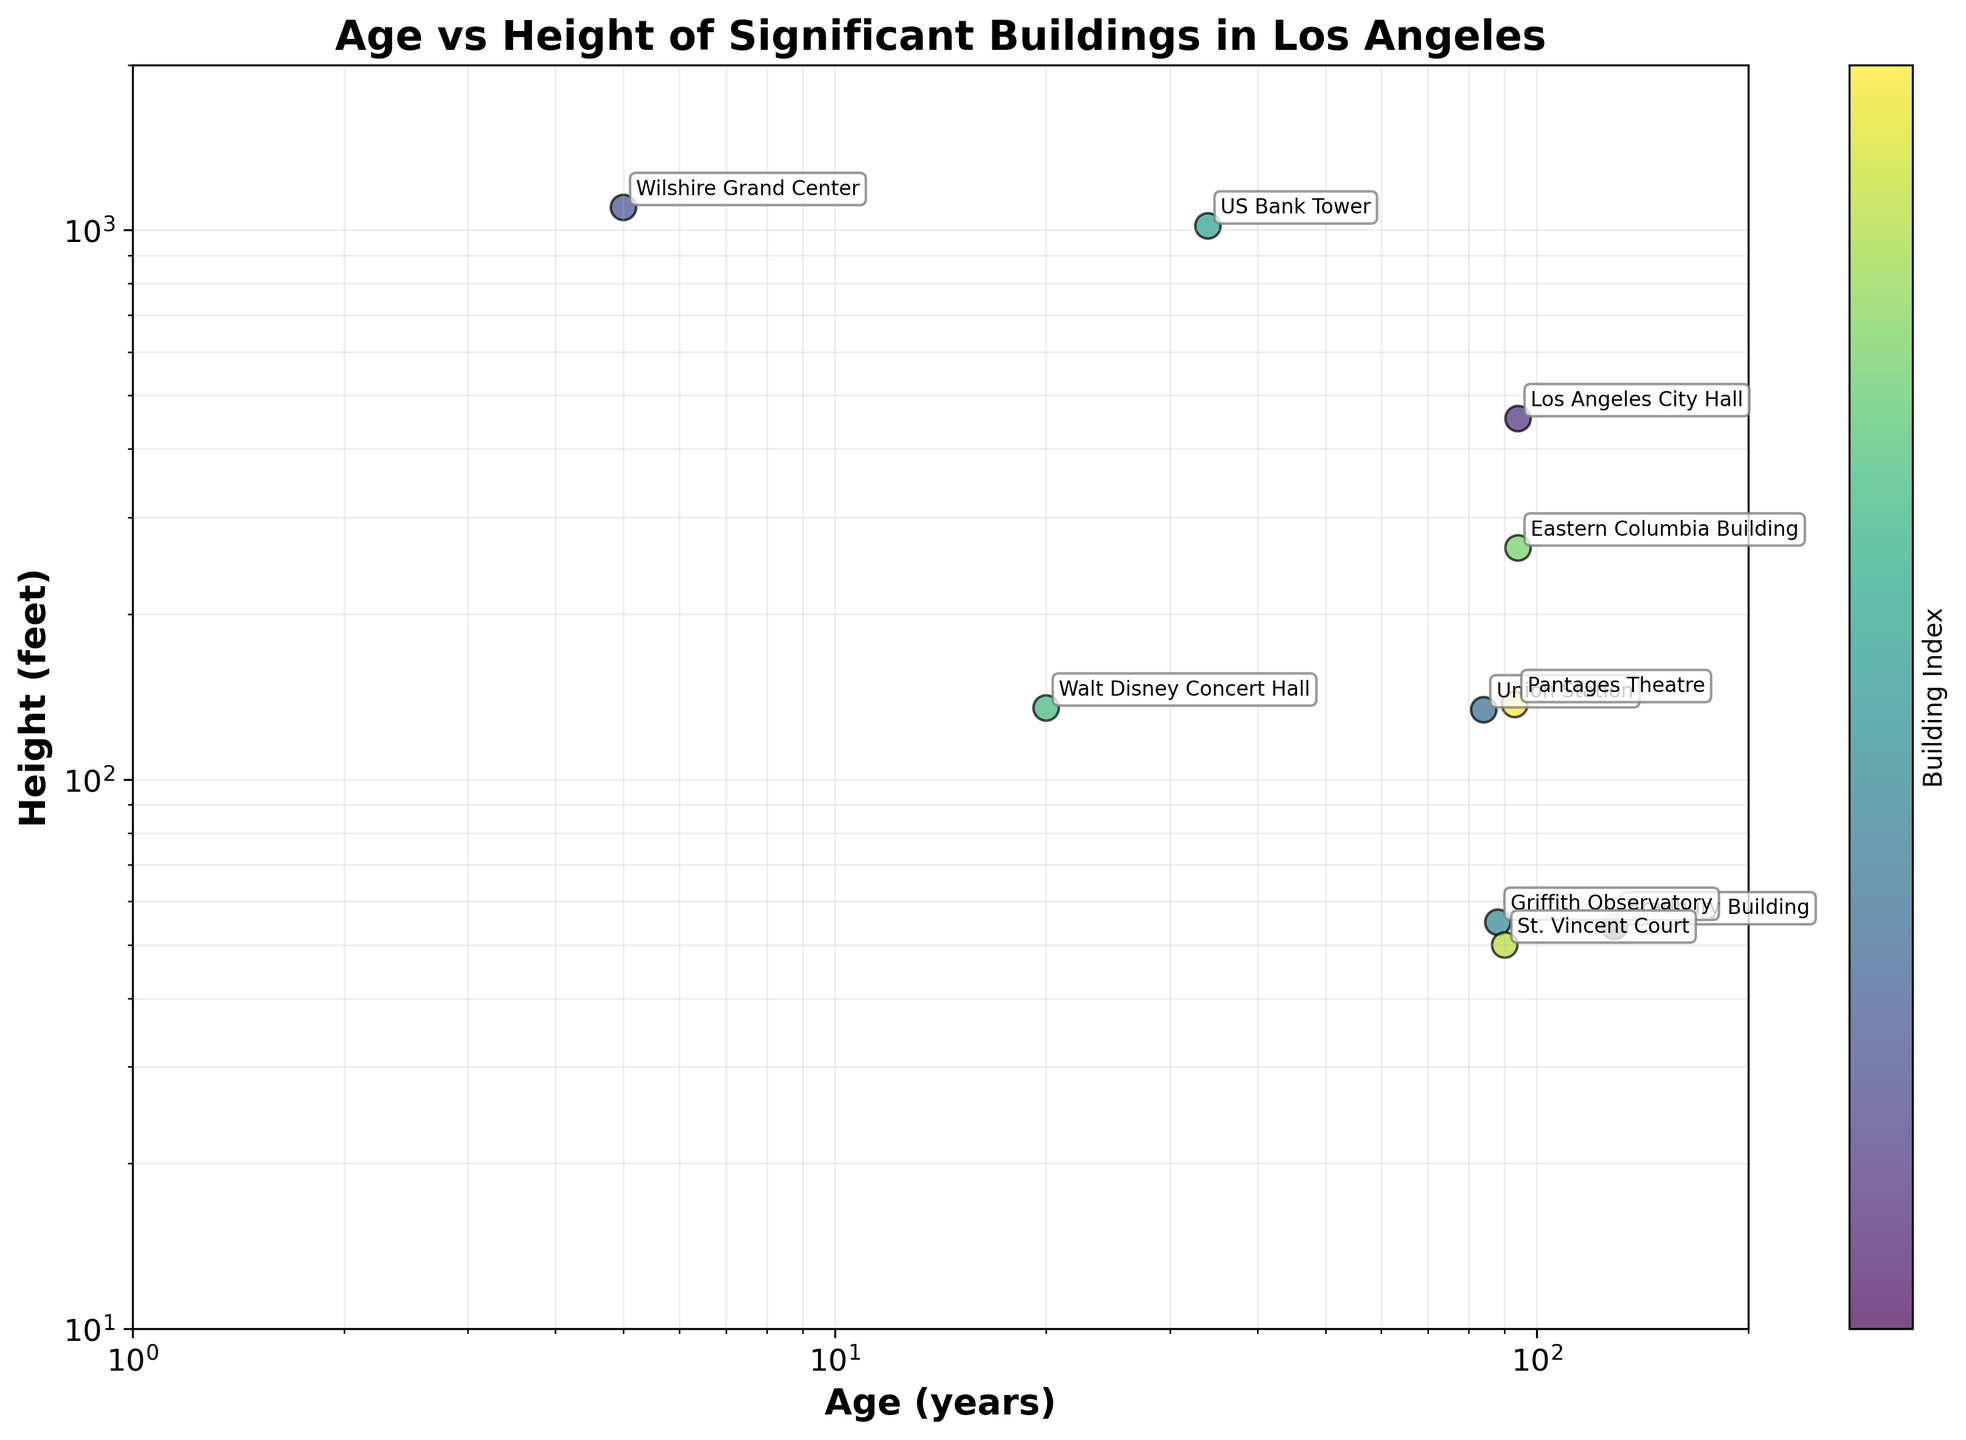What's the title of the plot? The title of the plot is typically found at the top center of the figure. In this case, it reads "Age vs Height of Significant Buildings in Los Angeles."
Answer: Age vs Height of Significant Buildings in Los Angeles Which building is the oldest in the plot? To determine the oldest building, look for the data point with the highest value on the x-axis (age in years). The "Bradbury Building" is marked as the building with the highest age value at 129 years.
Answer: Bradbury Building What is the height of the Wilshire Grand Center? Locate the Wilshire Grand Center label on the plot, and read the corresponding y-axis value for height. The Wilshire Grand Center has a height of 1100 feet.
Answer: 1100 feet Which building has the greatest height, and how old is it? Find the data point at the highest position on the y-axis. The Wilshire Grand Center has the greatest height of 1100 feet and is 5 years old.
Answer: Wilshire Grand Center, 5 years How does the height of the Los Angeles City Hall compare to that of the US Bank Tower? Compare the y-axis positions of Los Angeles City Hall and US Bank Tower. Los Angeles City Hall has a height of 454 feet, while the US Bank Tower has a height of 1018 feet. The US Bank Tower is taller.
Answer: US Bank Tower is taller How many buildings in the plot are over 500 feet tall? Identify data points above the 500-feet mark on the y-axis. The buildings are Wilshire Grand Center, Los Angeles City Hall, and US Bank Tower, totaling 3 buildings.
Answer: 3 buildings Which building is newer, Walt Disney Concert Hall or Griffith Observatory, and how do their heights compare? Compare the ages and heights of the Walt Disney Concert Hall and Griffith Observatory. The Walt Disney Concert Hall is newer at 20 years versus 88 years for Griffith Observatory. The Walt Disney Concert Hall is taller at 135 feet compared to 55 feet for Griffith Observatory.
Answer: Walt Disney Concert Hall is newer and taller What is the average height of the buildings older than 80 years? First, identify buildings older than 80 years: Bradbury Building, Los Angeles City Hall, Union Station, Griffith Observatory, Eastern Columbia Building, and St. Vincent Court. Calculate their heights' average: (54 + 454 + 134 + 55 + 264 + 50) / 6 = 168.5 feet.
Answer: 168.5 feet What is the relationship between the age and height of the buildings on a log scale? On a log scale scatter plot, observe the distribution pattern and trend of data points. There is no clear linear relationship indicating a direct correlation between the age and height of these buildings.
Answer: No clear correlation 